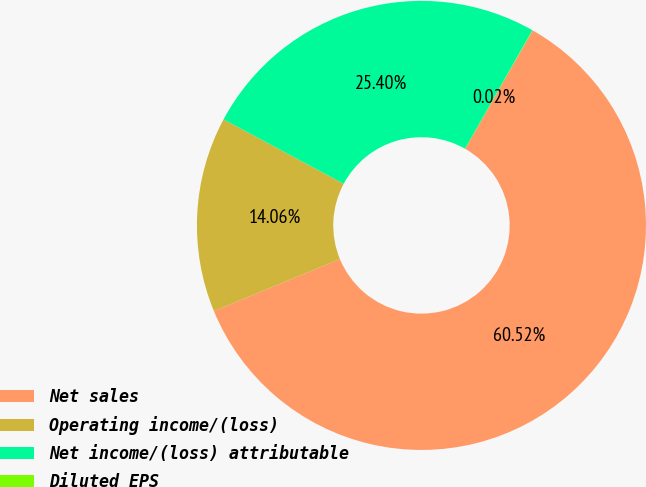<chart> <loc_0><loc_0><loc_500><loc_500><pie_chart><fcel>Net sales<fcel>Operating income/(loss)<fcel>Net income/(loss) attributable<fcel>Diluted EPS<nl><fcel>60.53%<fcel>14.06%<fcel>25.4%<fcel>0.02%<nl></chart> 